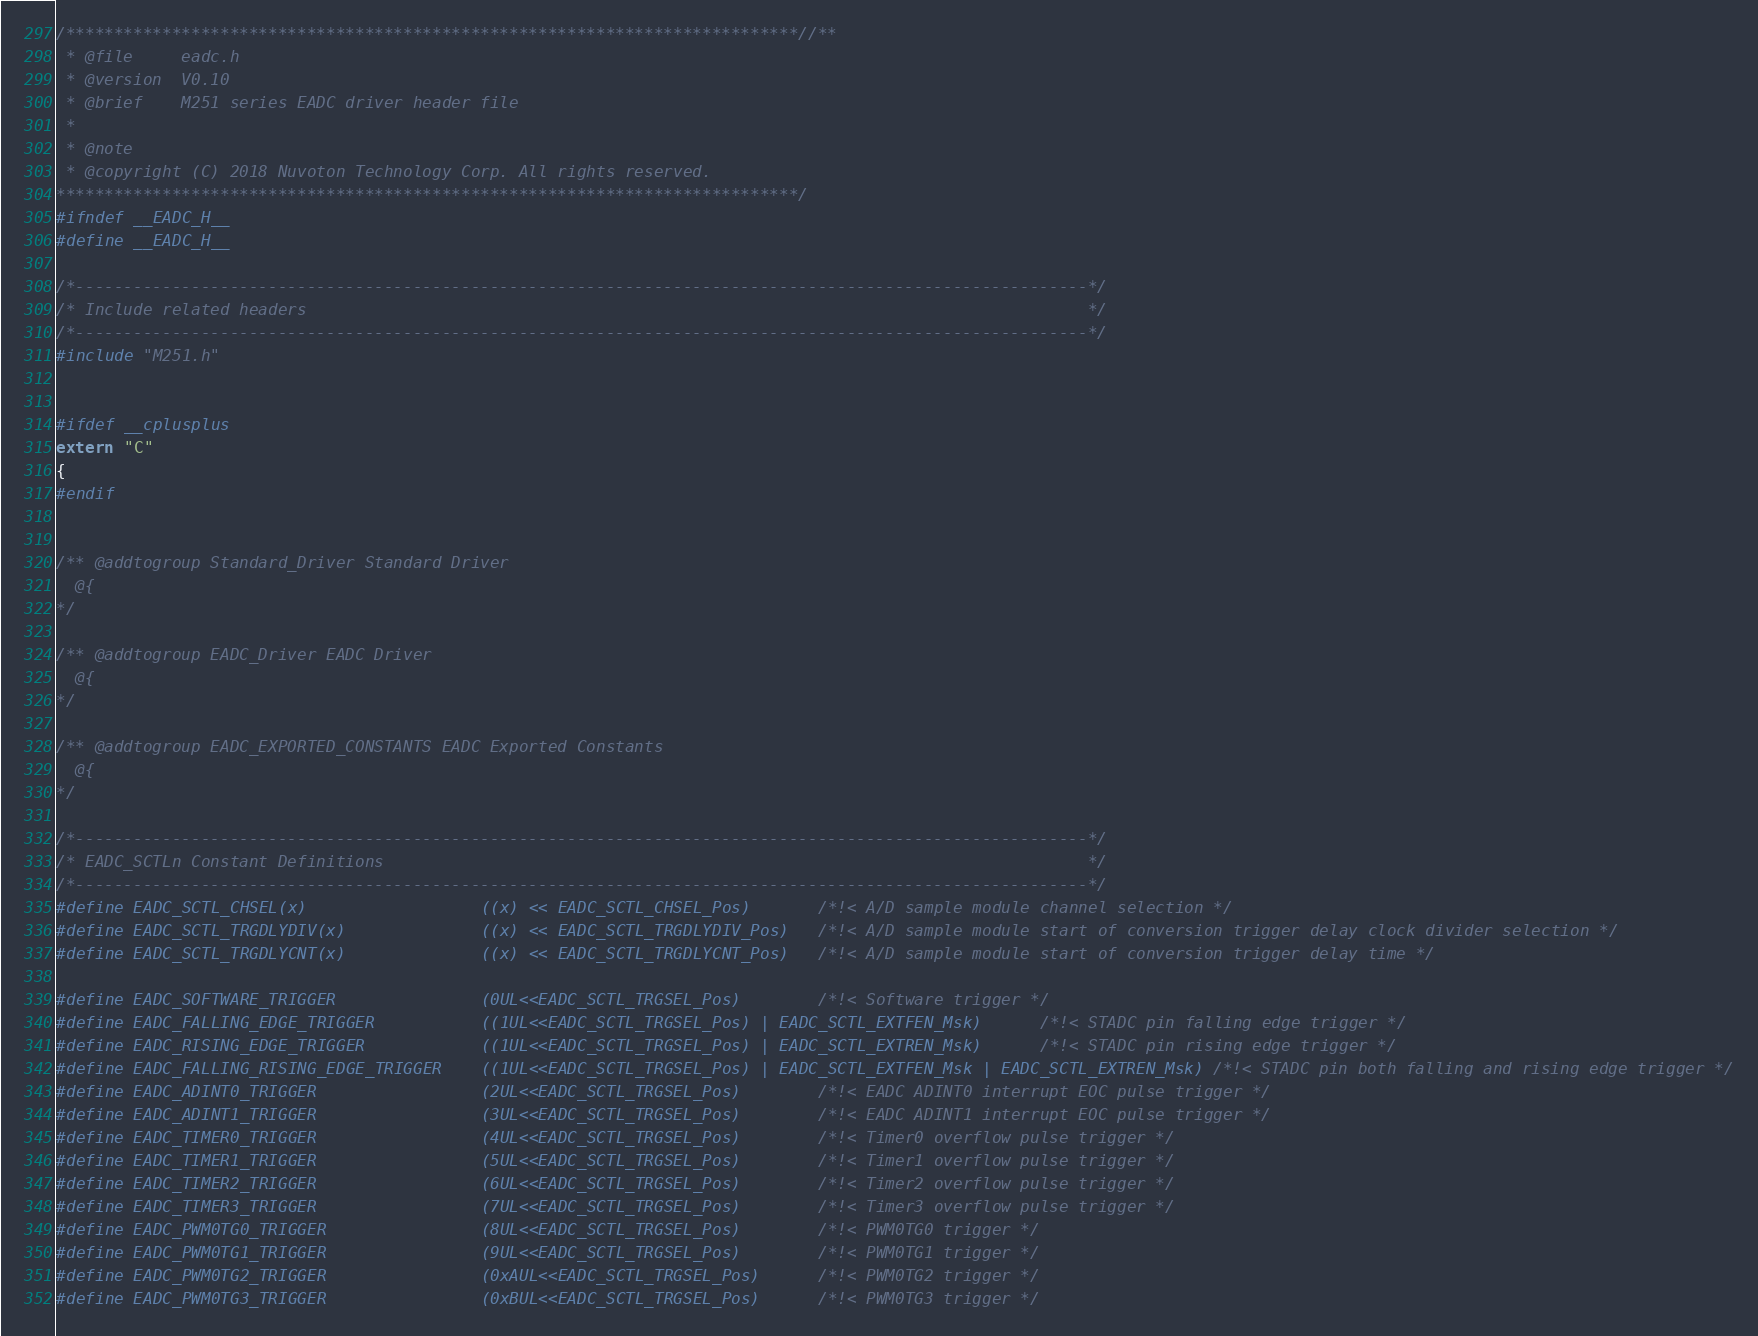Convert code to text. <code><loc_0><loc_0><loc_500><loc_500><_C_>/****************************************************************************//**
 * @file     eadc.h
 * @version  V0.10
 * @brief    M251 series EADC driver header file
 *
 * @note
 * @copyright (C) 2018 Nuvoton Technology Corp. All rights reserved.
*****************************************************************************/
#ifndef __EADC_H__
#define __EADC_H__

/*---------------------------------------------------------------------------------------------------------*/
/* Include related headers                                                                                 */
/*---------------------------------------------------------------------------------------------------------*/
#include "M251.h"


#ifdef __cplusplus
extern "C"
{
#endif


/** @addtogroup Standard_Driver Standard Driver
  @{
*/

/** @addtogroup EADC_Driver EADC Driver
  @{
*/

/** @addtogroup EADC_EXPORTED_CONSTANTS EADC Exported Constants
  @{
*/

/*---------------------------------------------------------------------------------------------------------*/
/* EADC_SCTLn Constant Definitions                                                                         */
/*---------------------------------------------------------------------------------------------------------*/
#define EADC_SCTL_CHSEL(x)                  ((x) << EADC_SCTL_CHSEL_Pos)       /*!< A/D sample module channel selection */
#define EADC_SCTL_TRGDLYDIV(x)              ((x) << EADC_SCTL_TRGDLYDIV_Pos)   /*!< A/D sample module start of conversion trigger delay clock divider selection */
#define EADC_SCTL_TRGDLYCNT(x)              ((x) << EADC_SCTL_TRGDLYCNT_Pos)   /*!< A/D sample module start of conversion trigger delay time */

#define EADC_SOFTWARE_TRIGGER               (0UL<<EADC_SCTL_TRGSEL_Pos)        /*!< Software trigger */
#define EADC_FALLING_EDGE_TRIGGER           ((1UL<<EADC_SCTL_TRGSEL_Pos) | EADC_SCTL_EXTFEN_Msk)      /*!< STADC pin falling edge trigger */
#define EADC_RISING_EDGE_TRIGGER            ((1UL<<EADC_SCTL_TRGSEL_Pos) | EADC_SCTL_EXTREN_Msk)      /*!< STADC pin rising edge trigger */
#define EADC_FALLING_RISING_EDGE_TRIGGER    ((1UL<<EADC_SCTL_TRGSEL_Pos) | EADC_SCTL_EXTFEN_Msk | EADC_SCTL_EXTREN_Msk) /*!< STADC pin both falling and rising edge trigger */
#define EADC_ADINT0_TRIGGER                 (2UL<<EADC_SCTL_TRGSEL_Pos)        /*!< EADC ADINT0 interrupt EOC pulse trigger */
#define EADC_ADINT1_TRIGGER                 (3UL<<EADC_SCTL_TRGSEL_Pos)        /*!< EADC ADINT1 interrupt EOC pulse trigger */
#define EADC_TIMER0_TRIGGER                 (4UL<<EADC_SCTL_TRGSEL_Pos)        /*!< Timer0 overflow pulse trigger */
#define EADC_TIMER1_TRIGGER                 (5UL<<EADC_SCTL_TRGSEL_Pos)        /*!< Timer1 overflow pulse trigger */
#define EADC_TIMER2_TRIGGER                 (6UL<<EADC_SCTL_TRGSEL_Pos)        /*!< Timer2 overflow pulse trigger */
#define EADC_TIMER3_TRIGGER                 (7UL<<EADC_SCTL_TRGSEL_Pos)        /*!< Timer3 overflow pulse trigger */
#define EADC_PWM0TG0_TRIGGER                (8UL<<EADC_SCTL_TRGSEL_Pos)        /*!< PWM0TG0 trigger */
#define EADC_PWM0TG1_TRIGGER                (9UL<<EADC_SCTL_TRGSEL_Pos)        /*!< PWM0TG1 trigger */
#define EADC_PWM0TG2_TRIGGER                (0xAUL<<EADC_SCTL_TRGSEL_Pos)      /*!< PWM0TG2 trigger */
#define EADC_PWM0TG3_TRIGGER                (0xBUL<<EADC_SCTL_TRGSEL_Pos)      /*!< PWM0TG3 trigger */</code> 